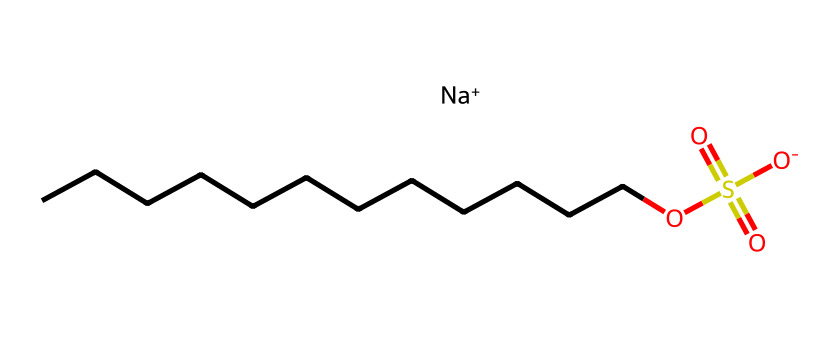how many carbon atoms are in sodium lauryl sulfate? The chemical structure shows a long hydrocarbon chain made up of 12 carbon atoms linked in a linear arrangement, identified by the continuous carbon chain from the SMILES notation.
Answer: 12 what is the functional group present in sodium lauryl sulfate? The chemical contains a sulfonate group, (S(=O)(=O)[O-]), which is characteristic of surfactants. This indicates the presence of a sulfur atom bonded to three oxygen atoms, one of which carries a negative charge.
Answer: sulfonate what is the charge of the sodium ion in sodium lauryl sulfate? In the SMILES representation, the presence of [Na+] indicates that the sodium ion carries a positive charge, typically balancing the negative charge of the sulfonate group.
Answer: positive what type of surfactant is sodium lauryl sulfate? The presence of both a long hydrophobic carbon chain and a hydrophilic sulfonate group indicates that sodium lauryl sulfate is an anionic surfactant, meaning it carries a negative charge.
Answer: anionic how does the length of the carbon chain affect the solubility of sodium lauryl sulfate? A longer carbon chain generally increases hydrophobic character and decreases solubility in water. However, the sulfonate group maintains some hydrophilicity, enabling the surfactant to effectively solubilize in aqueous solution. This balance allows it to function as a detergent.
Answer: decreased what are the implications of using sodium lauryl sulfate in screen protectors? Sodium lauryl sulfate can reduce surface tension, allowing better adherence to surfaces and enhancing the effectiveness of blue light-blocking coatings, while also providing some cleaning properties.
Answer: improved adhesion 